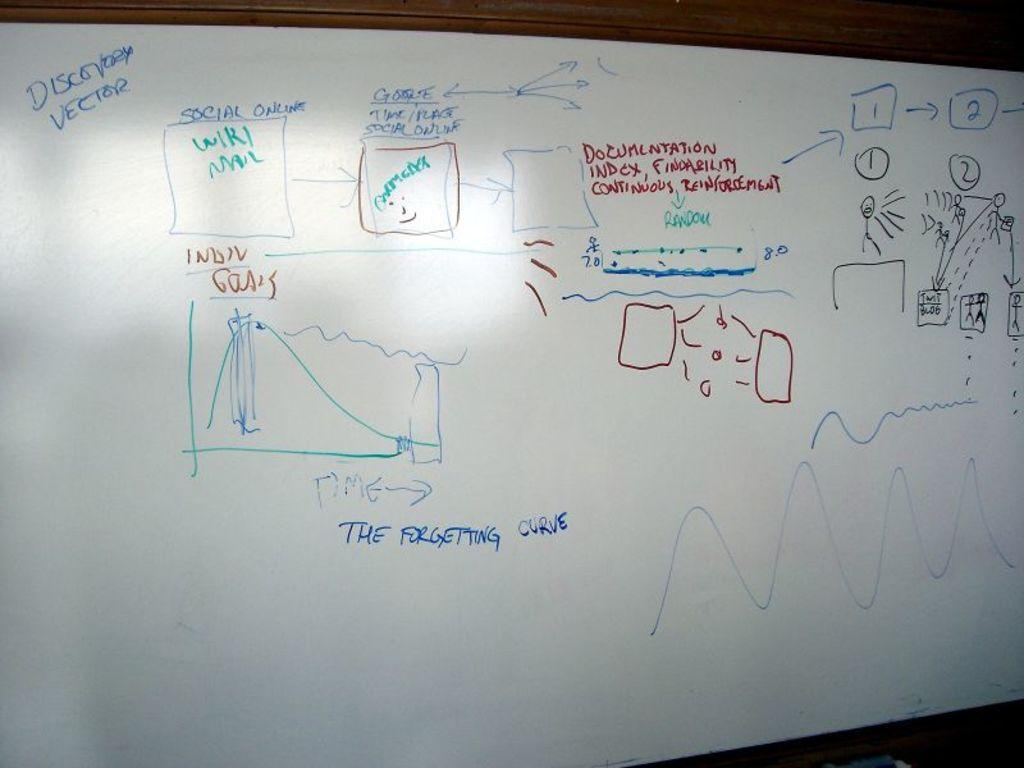Provide a one-sentence caption for the provided image. A whiteboard is partially covered with phrases like "The Forgetting Curve" as well as numbers and crude drawings. 